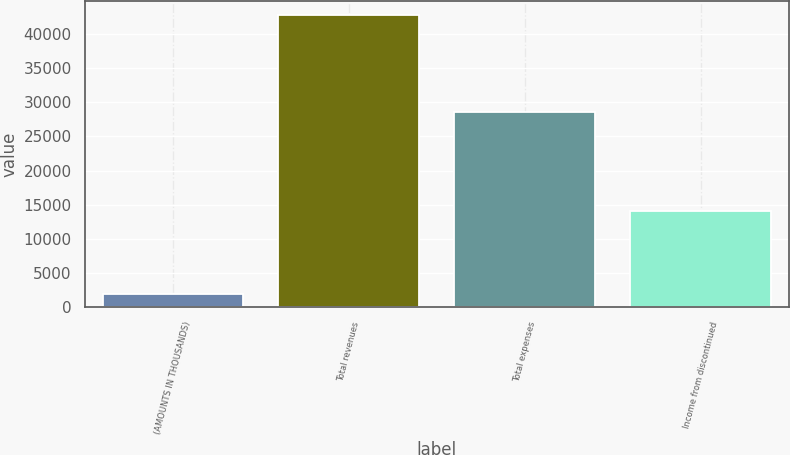<chart> <loc_0><loc_0><loc_500><loc_500><bar_chart><fcel>(AMOUNTS IN THOUSANDS)<fcel>Total revenues<fcel>Total expenses<fcel>Income from discontinued<nl><fcel>2003<fcel>42694<fcel>28621<fcel>14073<nl></chart> 